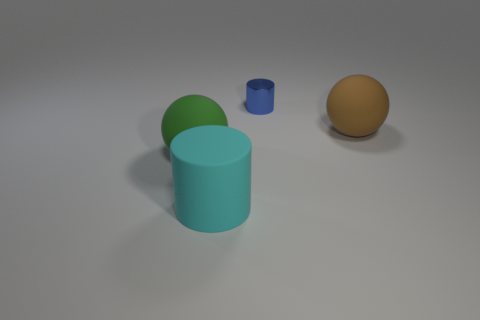What is the color of the thing on the right side of the shiny thing?
Offer a terse response. Brown. Does the blue shiny cylinder have the same size as the cyan cylinder?
Offer a terse response. No. What material is the ball that is right of the small cylinder behind the big brown thing?
Provide a succinct answer. Rubber. How many small shiny things have the same color as the large rubber cylinder?
Ensure brevity in your answer.  0. Is there anything else that is made of the same material as the brown sphere?
Keep it short and to the point. Yes. Are there fewer green balls that are behind the large cyan rubber cylinder than blue metal objects?
Offer a very short reply. No. What is the color of the ball that is in front of the big object behind the green rubber ball?
Your answer should be compact. Green. There is a matte ball on the right side of the large sphere on the left side of the large rubber thing that is to the right of the cyan object; what size is it?
Your answer should be very brief. Large. Are there fewer blue cylinders that are behind the tiny metal thing than large cyan cylinders that are behind the big cyan cylinder?
Make the answer very short. No. How many cyan things are made of the same material as the large green sphere?
Keep it short and to the point. 1. 